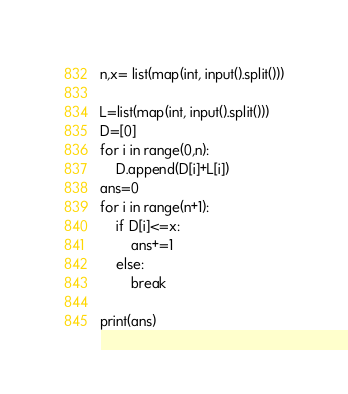<code> <loc_0><loc_0><loc_500><loc_500><_Python_>n,x= list(map(int, input().split()))

L=list(map(int, input().split()))
D=[0]
for i in range(0,n):
    D.append(D[i]+L[i])
ans=0
for i in range(n+1):
    if D[i]<=x:
        ans+=1
    else:
        break

print(ans)
</code> 